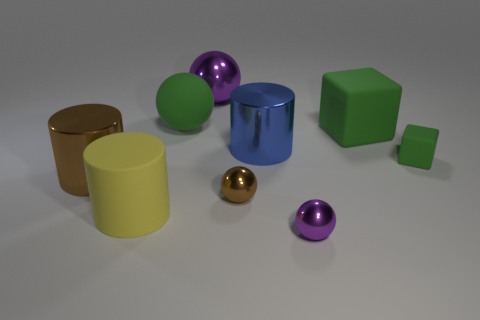Add 1 cyan matte blocks. How many objects exist? 10 Subtract all balls. How many objects are left? 5 Subtract 1 green spheres. How many objects are left? 8 Subtract all rubber cylinders. Subtract all large green matte balls. How many objects are left? 7 Add 7 large purple objects. How many large purple objects are left? 8 Add 4 brown matte balls. How many brown matte balls exist? 4 